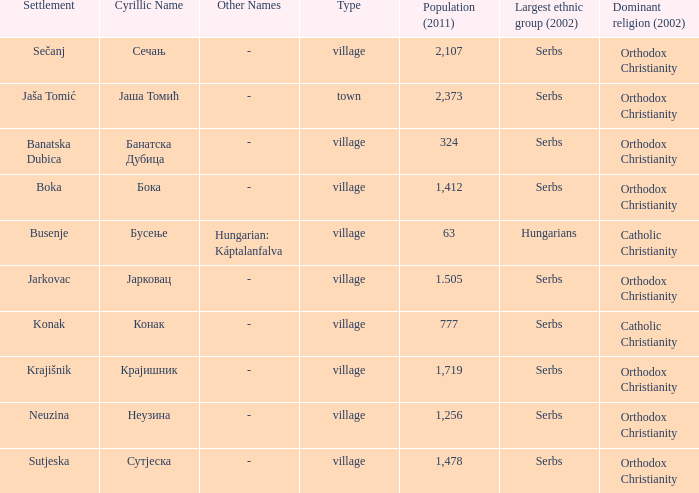What kind of type is  бока? Village. 